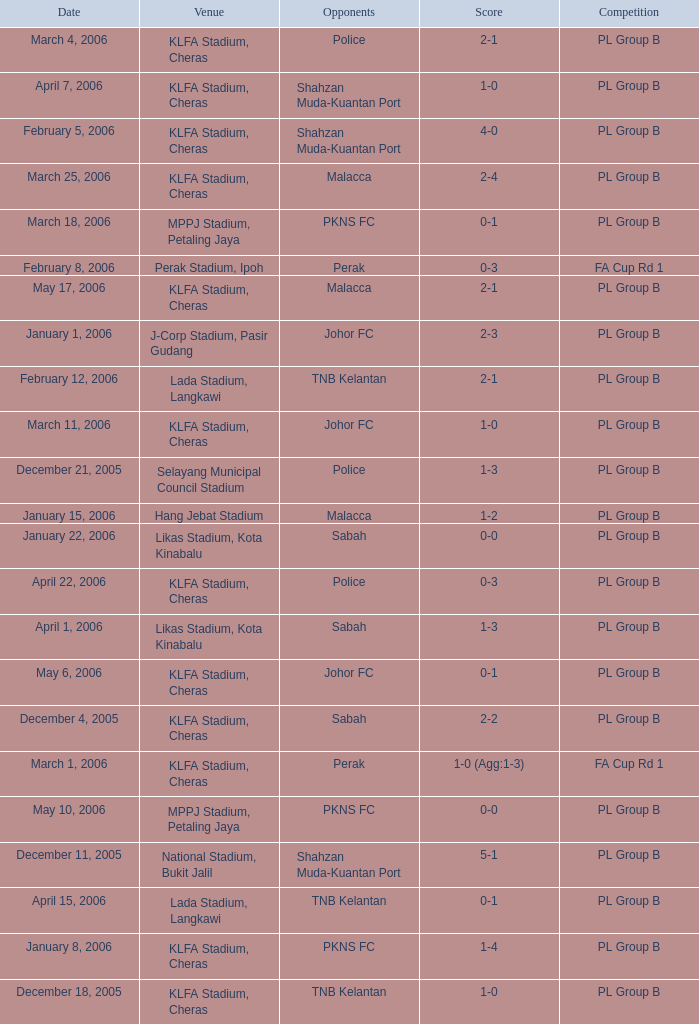Which Date has a Competition of pl group b, and Opponents of police, and a Venue of selayang municipal council stadium? December 21, 2005. 